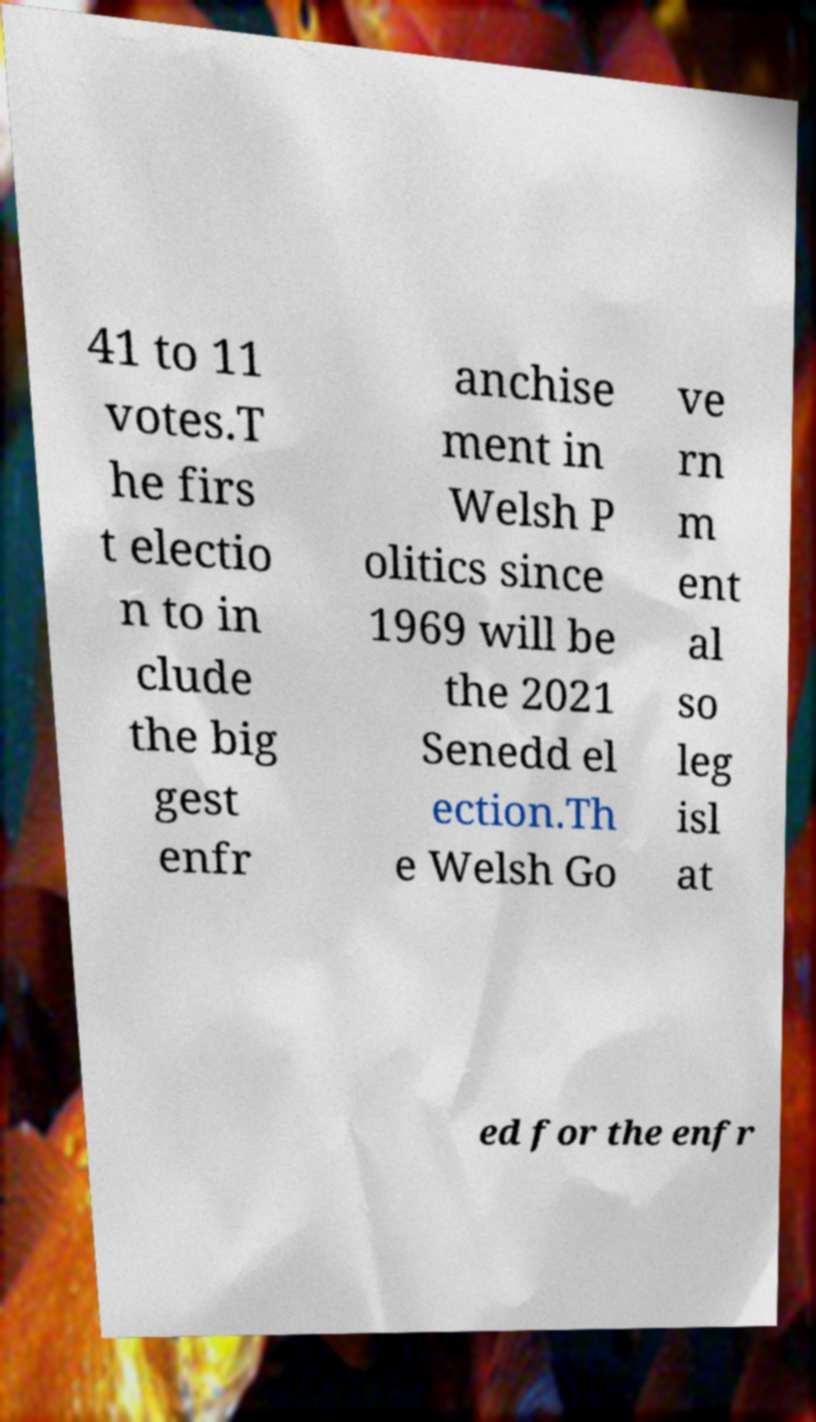There's text embedded in this image that I need extracted. Can you transcribe it verbatim? 41 to 11 votes.T he firs t electio n to in clude the big gest enfr anchise ment in Welsh P olitics since 1969 will be the 2021 Senedd el ection.Th e Welsh Go ve rn m ent al so leg isl at ed for the enfr 